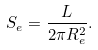Convert formula to latex. <formula><loc_0><loc_0><loc_500><loc_500>S _ { e } = \frac { L } { 2 \pi R _ { e } ^ { 2 } } .</formula> 